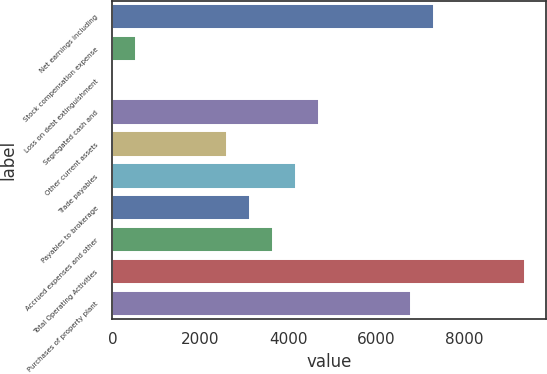Convert chart. <chart><loc_0><loc_0><loc_500><loc_500><bar_chart><fcel>Net earnings including<fcel>Stock compensation expense<fcel>Loss on debt extinguishment<fcel>Segregated cash and<fcel>Other current assets<fcel>Trade payables<fcel>Payables to brokerage<fcel>Accrued expenses and other<fcel>Total Operating Activities<fcel>Purchases of property plant<nl><fcel>7312.4<fcel>531.6<fcel>10<fcel>4704.4<fcel>2618<fcel>4182.8<fcel>3139.6<fcel>3661.2<fcel>9398.8<fcel>6790.8<nl></chart> 